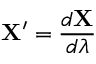<formula> <loc_0><loc_0><loc_500><loc_500>X ^ { \prime } = \frac { d X } { d \lambda }</formula> 